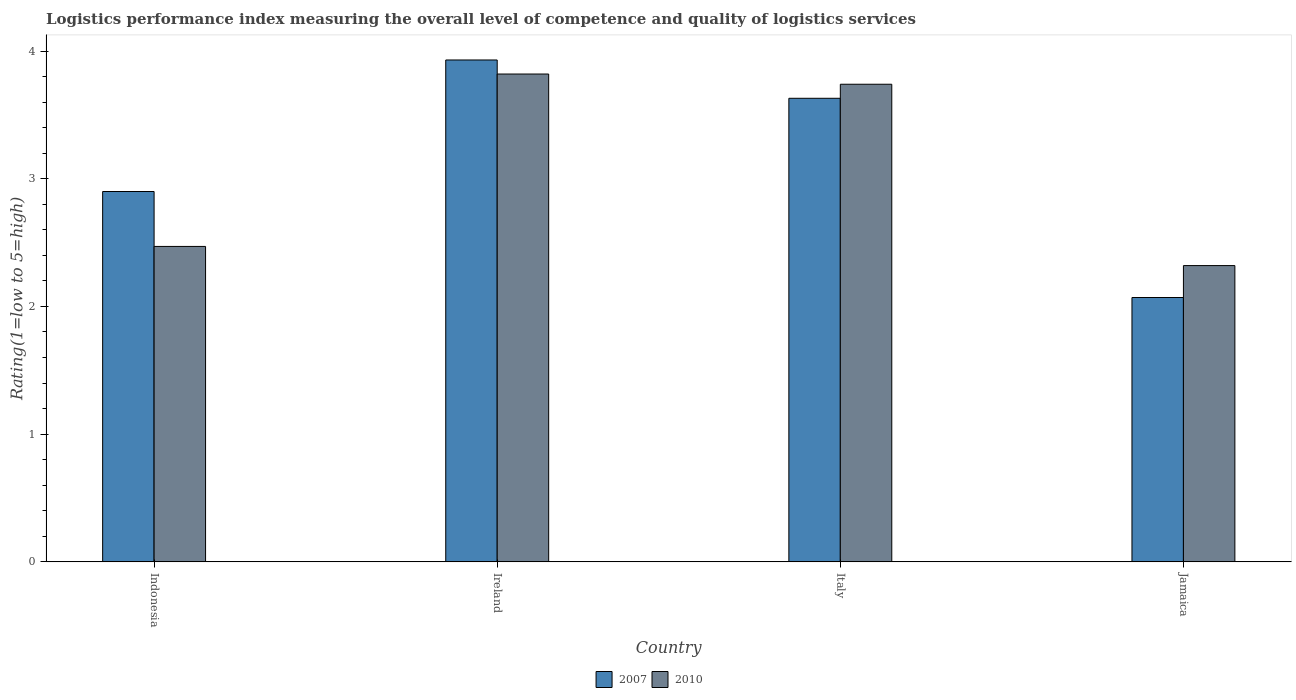How many different coloured bars are there?
Keep it short and to the point. 2. How many bars are there on the 4th tick from the left?
Provide a short and direct response. 2. How many bars are there on the 1st tick from the right?
Your response must be concise. 2. What is the label of the 4th group of bars from the left?
Your answer should be very brief. Jamaica. What is the Logistic performance index in 2007 in Jamaica?
Provide a succinct answer. 2.07. Across all countries, what is the maximum Logistic performance index in 2010?
Give a very brief answer. 3.82. Across all countries, what is the minimum Logistic performance index in 2010?
Offer a terse response. 2.32. In which country was the Logistic performance index in 2007 maximum?
Your answer should be compact. Ireland. In which country was the Logistic performance index in 2010 minimum?
Your response must be concise. Jamaica. What is the total Logistic performance index in 2010 in the graph?
Provide a short and direct response. 12.35. What is the difference between the Logistic performance index in 2010 in Indonesia and that in Italy?
Offer a very short reply. -1.27. What is the difference between the Logistic performance index in 2007 in Italy and the Logistic performance index in 2010 in Jamaica?
Keep it short and to the point. 1.31. What is the average Logistic performance index in 2010 per country?
Offer a terse response. 3.09. What is the difference between the Logistic performance index of/in 2007 and Logistic performance index of/in 2010 in Jamaica?
Make the answer very short. -0.25. In how many countries, is the Logistic performance index in 2010 greater than 1.6?
Provide a succinct answer. 4. What is the ratio of the Logistic performance index in 2007 in Italy to that in Jamaica?
Offer a terse response. 1.75. What is the difference between the highest and the second highest Logistic performance index in 2007?
Ensure brevity in your answer.  0.73. What is the difference between the highest and the lowest Logistic performance index in 2007?
Give a very brief answer. 1.86. What does the 1st bar from the left in Indonesia represents?
Offer a terse response. 2007. Are all the bars in the graph horizontal?
Keep it short and to the point. No. What is the difference between two consecutive major ticks on the Y-axis?
Keep it short and to the point. 1. Are the values on the major ticks of Y-axis written in scientific E-notation?
Provide a short and direct response. No. Where does the legend appear in the graph?
Ensure brevity in your answer.  Bottom center. What is the title of the graph?
Give a very brief answer. Logistics performance index measuring the overall level of competence and quality of logistics services. What is the label or title of the X-axis?
Provide a short and direct response. Country. What is the label or title of the Y-axis?
Keep it short and to the point. Rating(1=low to 5=high). What is the Rating(1=low to 5=high) of 2010 in Indonesia?
Offer a terse response. 2.47. What is the Rating(1=low to 5=high) of 2007 in Ireland?
Ensure brevity in your answer.  3.93. What is the Rating(1=low to 5=high) in 2010 in Ireland?
Offer a terse response. 3.82. What is the Rating(1=low to 5=high) of 2007 in Italy?
Your answer should be very brief. 3.63. What is the Rating(1=low to 5=high) in 2010 in Italy?
Your answer should be very brief. 3.74. What is the Rating(1=low to 5=high) of 2007 in Jamaica?
Offer a terse response. 2.07. What is the Rating(1=low to 5=high) of 2010 in Jamaica?
Keep it short and to the point. 2.32. Across all countries, what is the maximum Rating(1=low to 5=high) of 2007?
Your answer should be compact. 3.93. Across all countries, what is the maximum Rating(1=low to 5=high) of 2010?
Your answer should be very brief. 3.82. Across all countries, what is the minimum Rating(1=low to 5=high) in 2007?
Offer a terse response. 2.07. Across all countries, what is the minimum Rating(1=low to 5=high) of 2010?
Your answer should be very brief. 2.32. What is the total Rating(1=low to 5=high) of 2007 in the graph?
Your answer should be very brief. 12.53. What is the total Rating(1=low to 5=high) of 2010 in the graph?
Give a very brief answer. 12.35. What is the difference between the Rating(1=low to 5=high) in 2007 in Indonesia and that in Ireland?
Your answer should be very brief. -1.03. What is the difference between the Rating(1=low to 5=high) in 2010 in Indonesia and that in Ireland?
Make the answer very short. -1.35. What is the difference between the Rating(1=low to 5=high) of 2007 in Indonesia and that in Italy?
Your response must be concise. -0.73. What is the difference between the Rating(1=low to 5=high) of 2010 in Indonesia and that in Italy?
Give a very brief answer. -1.27. What is the difference between the Rating(1=low to 5=high) in 2007 in Indonesia and that in Jamaica?
Keep it short and to the point. 0.83. What is the difference between the Rating(1=low to 5=high) in 2010 in Indonesia and that in Jamaica?
Your answer should be compact. 0.15. What is the difference between the Rating(1=low to 5=high) in 2007 in Ireland and that in Jamaica?
Provide a succinct answer. 1.86. What is the difference between the Rating(1=low to 5=high) in 2010 in Ireland and that in Jamaica?
Make the answer very short. 1.5. What is the difference between the Rating(1=low to 5=high) in 2007 in Italy and that in Jamaica?
Give a very brief answer. 1.56. What is the difference between the Rating(1=low to 5=high) in 2010 in Italy and that in Jamaica?
Offer a terse response. 1.42. What is the difference between the Rating(1=low to 5=high) of 2007 in Indonesia and the Rating(1=low to 5=high) of 2010 in Ireland?
Make the answer very short. -0.92. What is the difference between the Rating(1=low to 5=high) in 2007 in Indonesia and the Rating(1=low to 5=high) in 2010 in Italy?
Keep it short and to the point. -0.84. What is the difference between the Rating(1=low to 5=high) of 2007 in Indonesia and the Rating(1=low to 5=high) of 2010 in Jamaica?
Offer a terse response. 0.58. What is the difference between the Rating(1=low to 5=high) of 2007 in Ireland and the Rating(1=low to 5=high) of 2010 in Italy?
Make the answer very short. 0.19. What is the difference between the Rating(1=low to 5=high) of 2007 in Ireland and the Rating(1=low to 5=high) of 2010 in Jamaica?
Ensure brevity in your answer.  1.61. What is the difference between the Rating(1=low to 5=high) of 2007 in Italy and the Rating(1=low to 5=high) of 2010 in Jamaica?
Provide a succinct answer. 1.31. What is the average Rating(1=low to 5=high) in 2007 per country?
Make the answer very short. 3.13. What is the average Rating(1=low to 5=high) in 2010 per country?
Offer a very short reply. 3.09. What is the difference between the Rating(1=low to 5=high) of 2007 and Rating(1=low to 5=high) of 2010 in Indonesia?
Ensure brevity in your answer.  0.43. What is the difference between the Rating(1=low to 5=high) of 2007 and Rating(1=low to 5=high) of 2010 in Ireland?
Your answer should be very brief. 0.11. What is the difference between the Rating(1=low to 5=high) of 2007 and Rating(1=low to 5=high) of 2010 in Italy?
Provide a succinct answer. -0.11. What is the difference between the Rating(1=low to 5=high) of 2007 and Rating(1=low to 5=high) of 2010 in Jamaica?
Offer a terse response. -0.25. What is the ratio of the Rating(1=low to 5=high) of 2007 in Indonesia to that in Ireland?
Provide a succinct answer. 0.74. What is the ratio of the Rating(1=low to 5=high) of 2010 in Indonesia to that in Ireland?
Your response must be concise. 0.65. What is the ratio of the Rating(1=low to 5=high) of 2007 in Indonesia to that in Italy?
Provide a succinct answer. 0.8. What is the ratio of the Rating(1=low to 5=high) of 2010 in Indonesia to that in Italy?
Keep it short and to the point. 0.66. What is the ratio of the Rating(1=low to 5=high) of 2007 in Indonesia to that in Jamaica?
Ensure brevity in your answer.  1.4. What is the ratio of the Rating(1=low to 5=high) of 2010 in Indonesia to that in Jamaica?
Offer a very short reply. 1.06. What is the ratio of the Rating(1=low to 5=high) of 2007 in Ireland to that in Italy?
Ensure brevity in your answer.  1.08. What is the ratio of the Rating(1=low to 5=high) in 2010 in Ireland to that in Italy?
Provide a succinct answer. 1.02. What is the ratio of the Rating(1=low to 5=high) in 2007 in Ireland to that in Jamaica?
Offer a very short reply. 1.9. What is the ratio of the Rating(1=low to 5=high) of 2010 in Ireland to that in Jamaica?
Your answer should be compact. 1.65. What is the ratio of the Rating(1=low to 5=high) of 2007 in Italy to that in Jamaica?
Your answer should be compact. 1.75. What is the ratio of the Rating(1=low to 5=high) in 2010 in Italy to that in Jamaica?
Give a very brief answer. 1.61. What is the difference between the highest and the second highest Rating(1=low to 5=high) in 2007?
Provide a short and direct response. 0.3. What is the difference between the highest and the second highest Rating(1=low to 5=high) in 2010?
Your answer should be very brief. 0.08. What is the difference between the highest and the lowest Rating(1=low to 5=high) of 2007?
Make the answer very short. 1.86. 